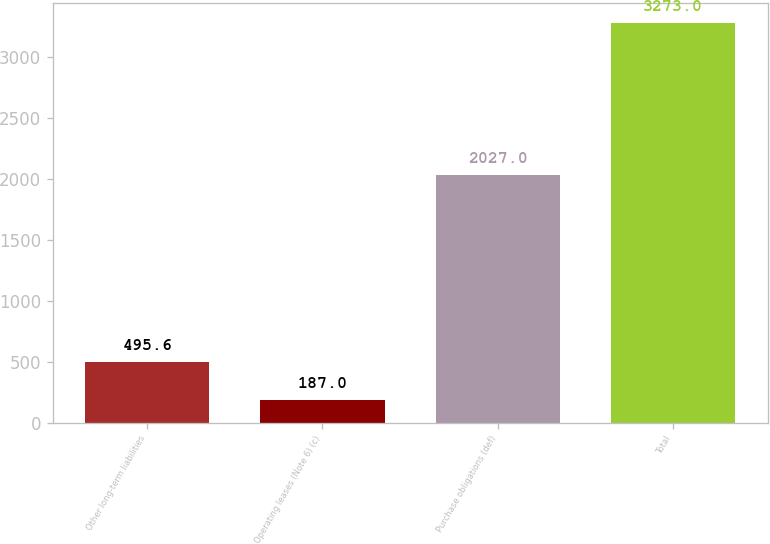<chart> <loc_0><loc_0><loc_500><loc_500><bar_chart><fcel>Other long-term liabilities<fcel>Operating leases (Note 6) (c)<fcel>Purchase obligations (def)<fcel>Total<nl><fcel>495.6<fcel>187<fcel>2027<fcel>3273<nl></chart> 